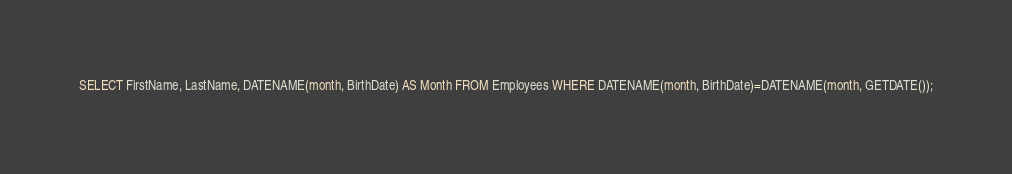<code> <loc_0><loc_0><loc_500><loc_500><_SQL_>SELECT FirstName, LastName, DATENAME(month, BirthDate) AS Month FROM Employees WHERE DATENAME(month, BirthDate)=DATENAME(month, GETDATE());</code> 